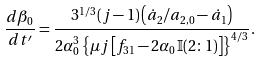Convert formula to latex. <formula><loc_0><loc_0><loc_500><loc_500>\frac { d \beta _ { 0 } } { d t ^ { \prime } } = \frac { 3 ^ { 1 / 3 } ( j - 1 ) \left ( \dot { a } _ { 2 } / a _ { 2 , 0 } - \dot { a } _ { 1 } \right ) } { 2 \alpha _ { 0 } ^ { 3 } \left \{ \mu j \left [ f _ { 3 1 } - 2 \alpha _ { 0 } \mathbb { I } ( 2 \colon 1 ) \right ] \right \} ^ { 4 / 3 } } .</formula> 